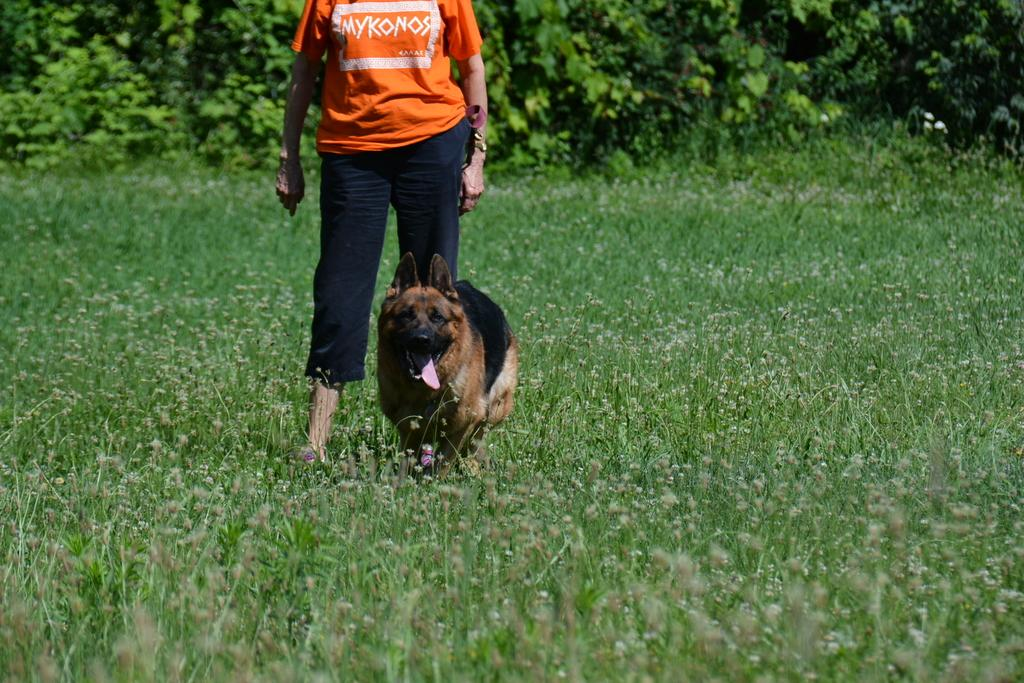What type of animal is in the image? There is a dog in the image. Who or what else is in the image? There is a person in the image. What kind of environment is depicted in the image? Greenery is present in the image. What type of legal advice is the dog providing to the person in the image? There is no indication in the image that the dog is providing legal advice or that the person is seeking legal advice. 